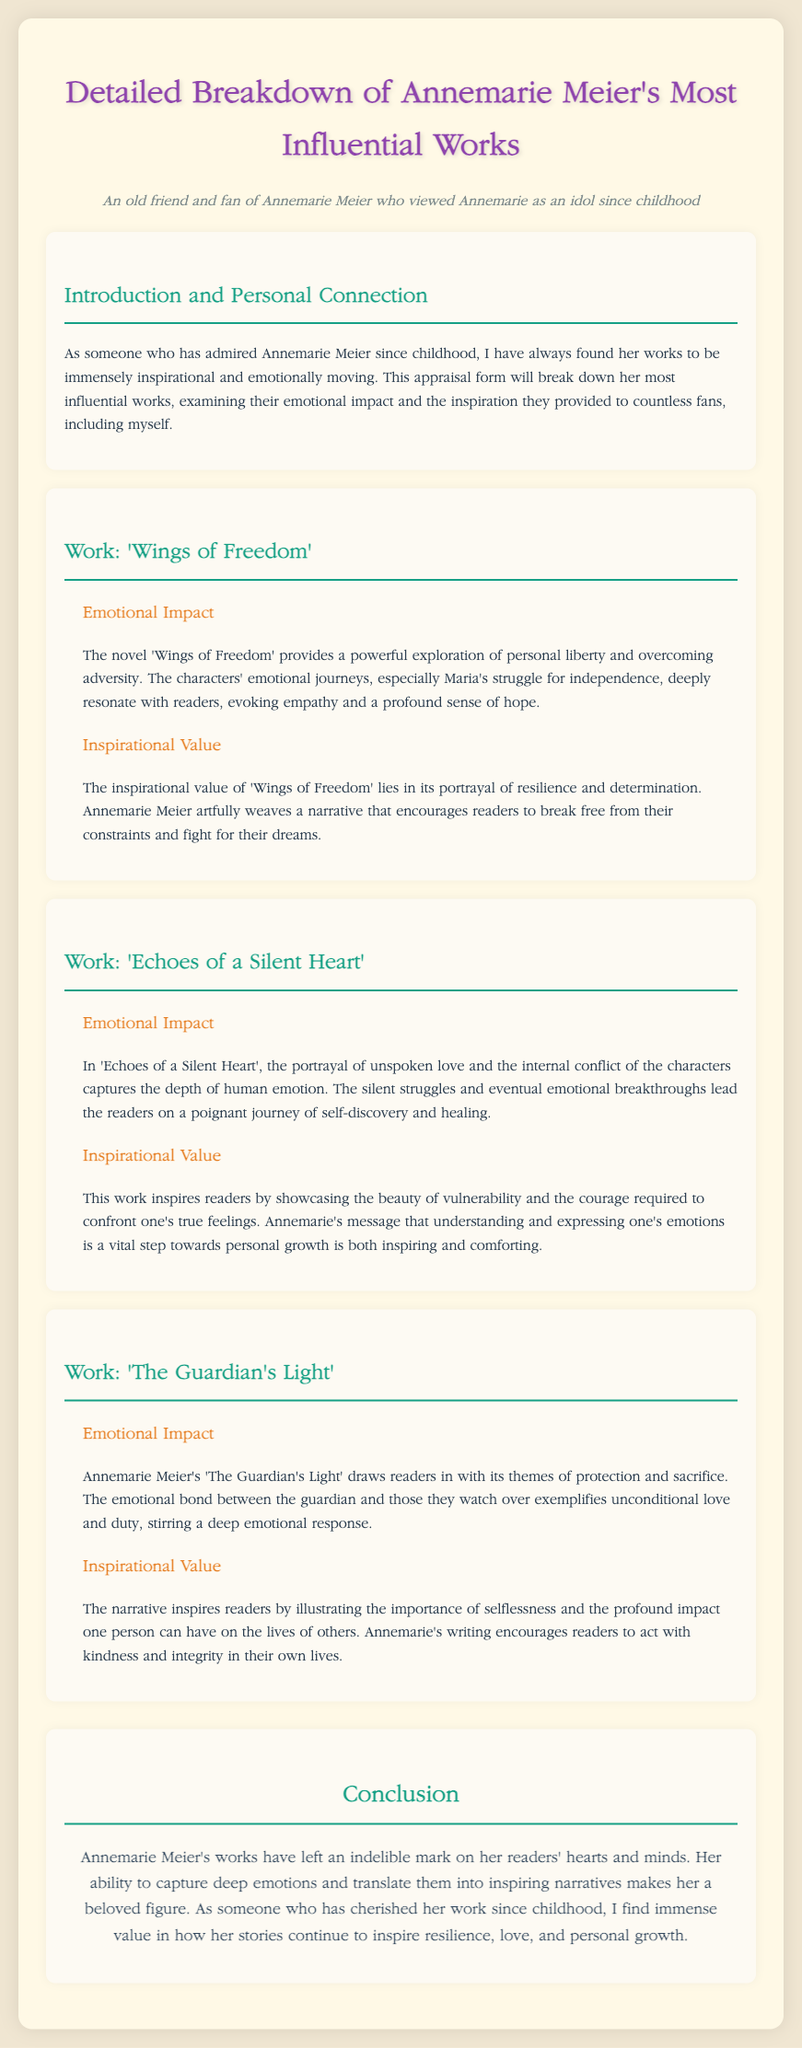what is the title of the document? The title of the document can be found in the header, highlighting its focus on Annemarie Meier's works.
Answer: Detailed Breakdown of Annemarie Meier's Most Influential Works who is the author of 'Wings of Freedom'? The author of 'Wings of Freedom', as indicated in the document, is Annemarie Meier.
Answer: Annemarie Meier what is the emotional impact of 'Echoes of a Silent Heart'? The emotional impact description for 'Echoes of a Silent Heart' illustrates the themes of love and internal conflict.
Answer: Unspoken love and internal conflict what is the main theme of 'The Guardian's Light'? The main theme associated with 'The Guardian's Light' focuses on protection and sacrifice.
Answer: Protection and sacrifice how does 'Wings of Freedom' inspire readers? The document notes that 'Wings of Freedom' inspires through its narrative about resilience and determination.
Answer: Resilience and determination what does the conclusion highlight about Annemarie Meier's works? The conclusion summarizes the overarching impact of Annemarie Meier's works on her readers.
Answer: Indelible mark on her readers' hearts and minds what is the inspirational value of 'Echoes of a Silent Heart'? The inspirational value section describes understanding emotions as vital for personal growth.
Answer: Understanding and expressing one's emotions what literary technique is prominent in Annemarie Meier's writing? The document emphasizes Annemarie's ability to capture deep emotions in her narratives.
Answer: Capturing deep emotions how many works are discussed in the document? The document explicitly breaks down three influential works by Annemarie Meier.
Answer: Three works 